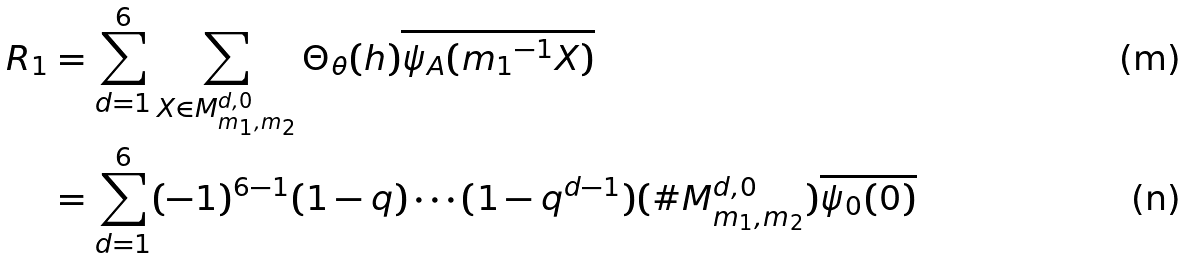<formula> <loc_0><loc_0><loc_500><loc_500>R _ { 1 } & = \sum _ { d = 1 } ^ { 6 } \sum _ { X \in M _ { m _ { 1 } , m _ { 2 } } ^ { d , 0 } } \Theta _ { \theta } ( h ) \overline { \psi _ { A } ( { m _ { 1 } } ^ { - 1 } X ) } \\ & = \sum _ { d = 1 } ^ { 6 } ( - 1 ) ^ { 6 - 1 } ( 1 - q ) \cdots ( 1 - q ^ { d - 1 } ) ( \# M _ { m _ { 1 } , m _ { 2 } } ^ { d , 0 } ) \overline { \psi _ { 0 } ( 0 ) }</formula> 